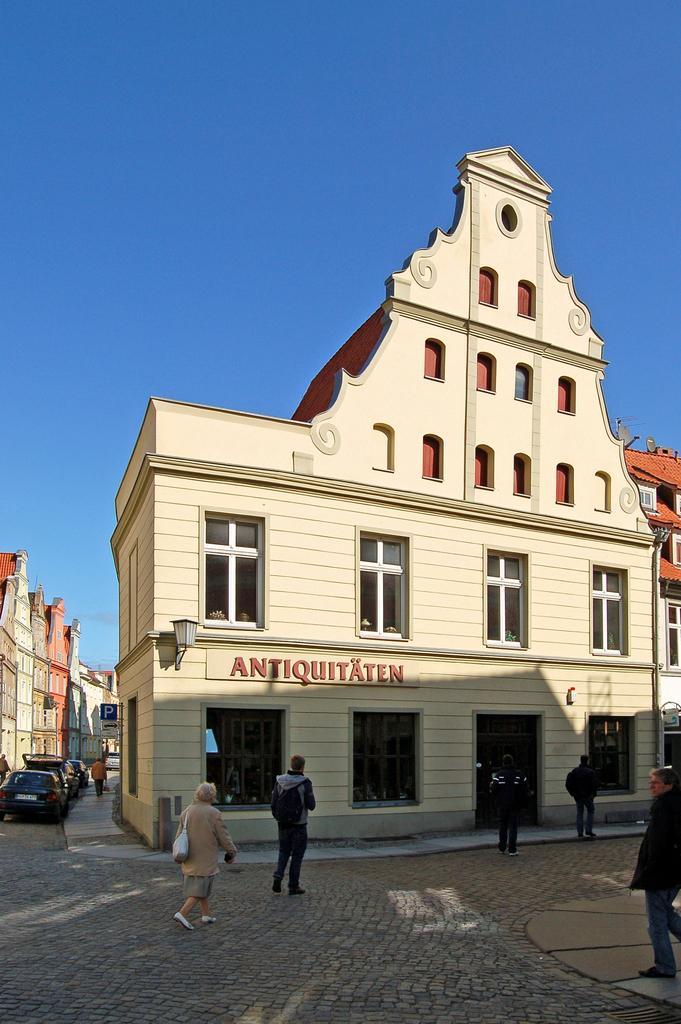What is this building?
Provide a succinct answer. Antiquitaten. What type of store is this?
Provide a succinct answer. Antiquitaten. 